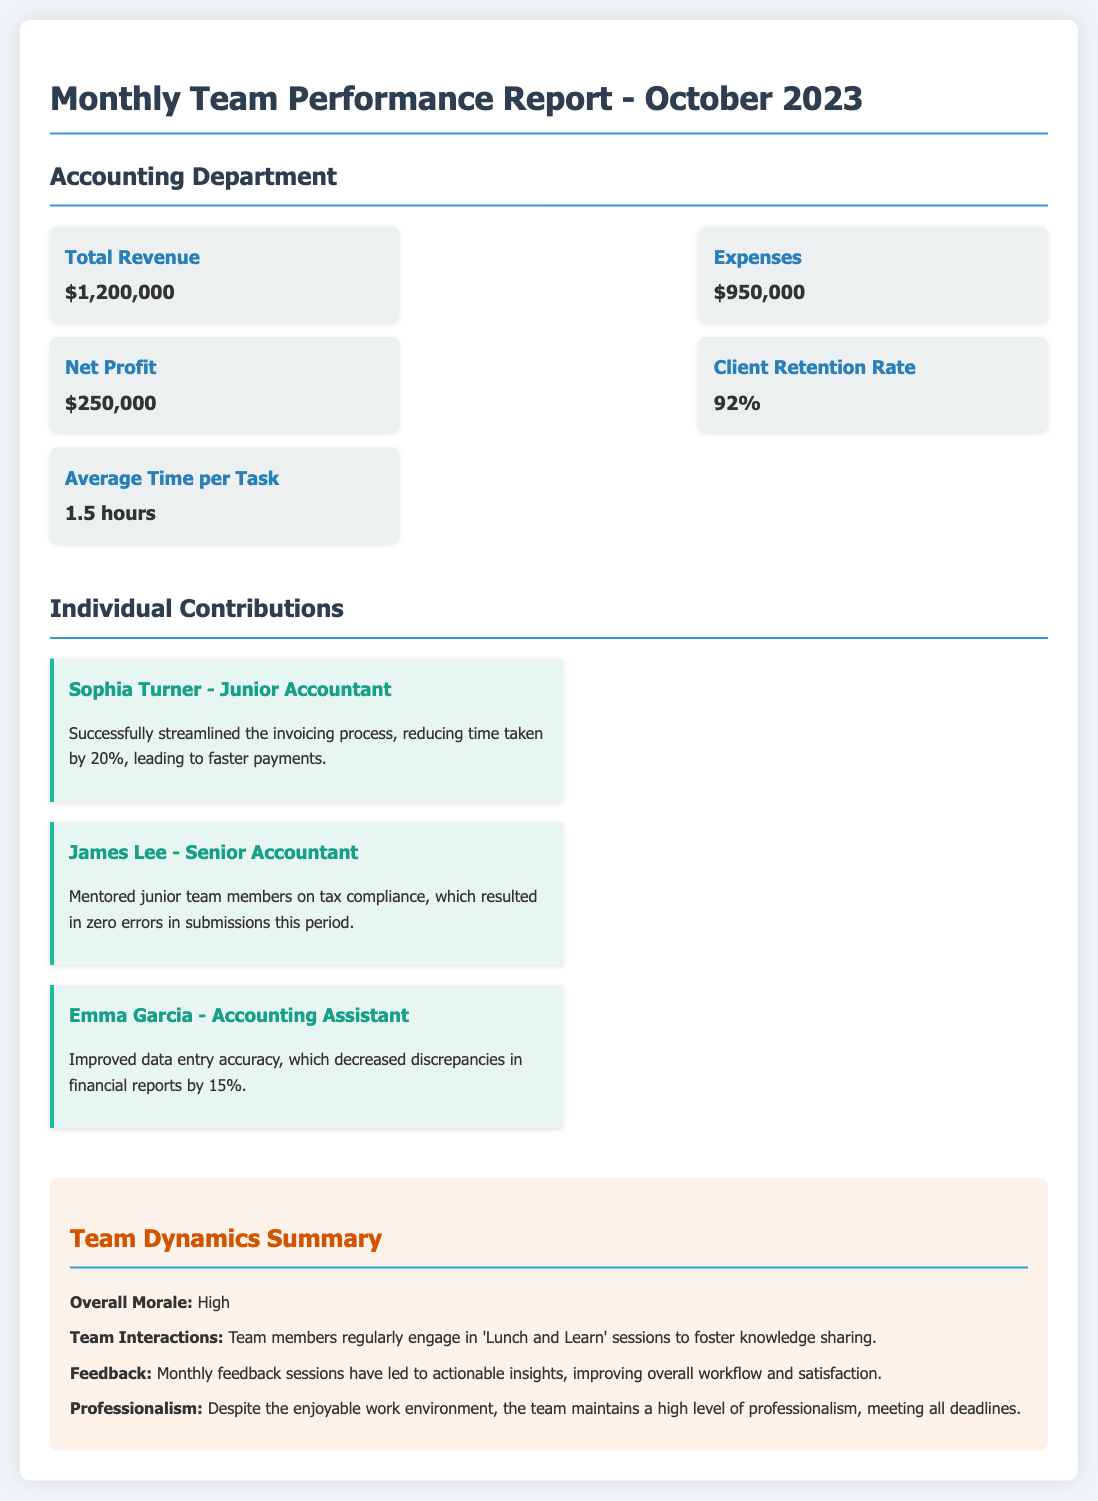What is the total revenue? The total revenue is explicitly stated in the metrics section of the document.
Answer: $1,200,000 What is the Net Profit? Net Profit is a key metric that shows the difference between total revenue and expenses, as outlined in the metrics.
Answer: $250,000 Who is the Junior Accountant? The document lists individual contributions, identifying Sophia Turner as the Junior Accountant.
Answer: Sophia Turner What improvement did Emma Garcia make? The contributions section highlights Emma Garcia's improvement that led to decreased discrepancies in financial reports.
Answer: Data entry accuracy What is the Client Retention Rate? This metric is presented in the metrics section as a measure of customer loyalty and satisfaction.
Answer: 92% How much did Sophia Turner reduce time spent on the invoicing process? This detail can be found in the individual contributions, describing her effectiveness in streamlining processes.
Answer: 20% What is the overall morale of the team? The team dynamics summary mentions the overall morale in a straightforward assessment of team spirit.
Answer: High What did James Lee do to contribute to the team? The document states his specific contribution towards mentoring and ensuring error-free submissions.
Answer: Mentored junior team members What is mentioned about team interactions? This is mentioned in the team dynamics section, highlighting how the team engages in knowledge-sharing activities.
Answer: 'Lunch and Learn' sessions 